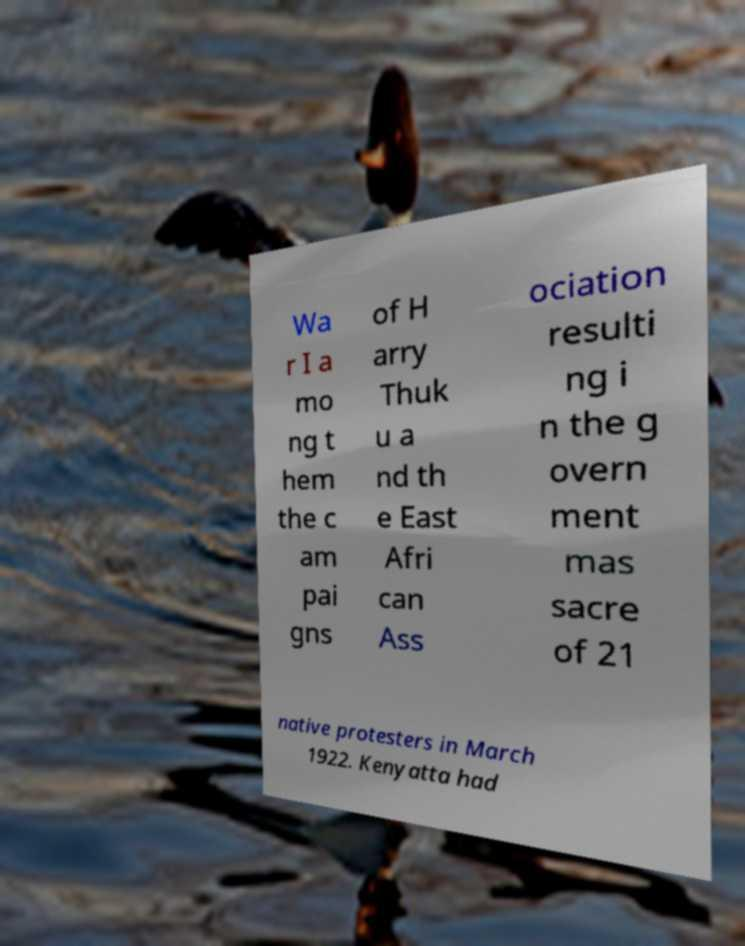There's text embedded in this image that I need extracted. Can you transcribe it verbatim? Wa r I a mo ng t hem the c am pai gns of H arry Thuk u a nd th e East Afri can Ass ociation resulti ng i n the g overn ment mas sacre of 21 native protesters in March 1922. Kenyatta had 